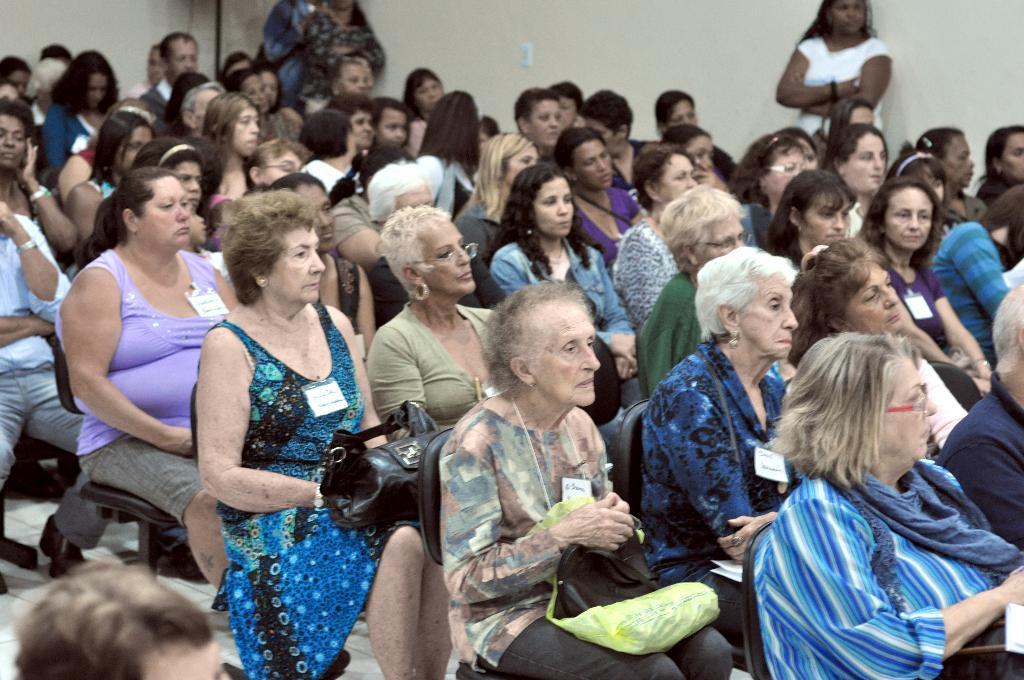Can you describe this image briefly? In this picture I can see in the middle a group of people are sitting on the chairs and looking at the right side. At the top two persons are standing near the wall. 